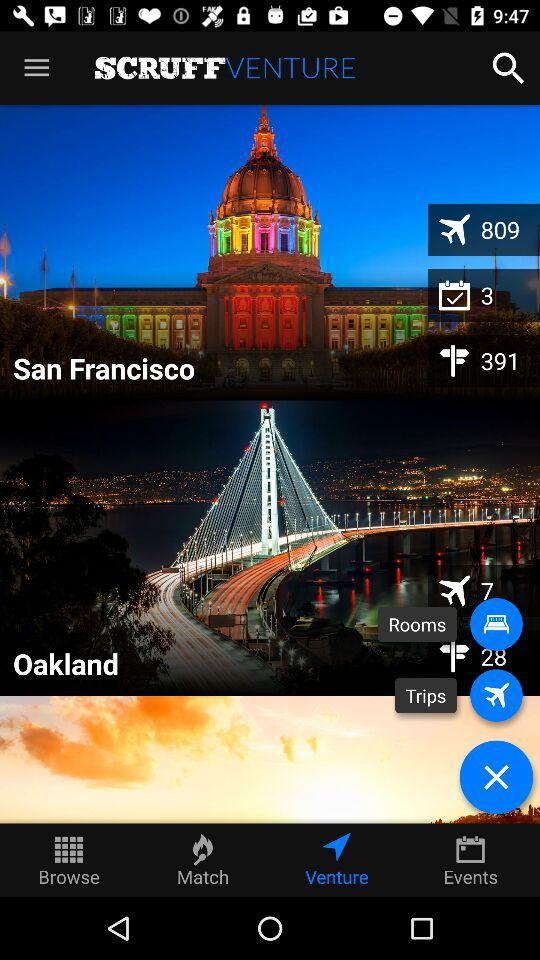Which option is selected? The selected option is "Venture". 